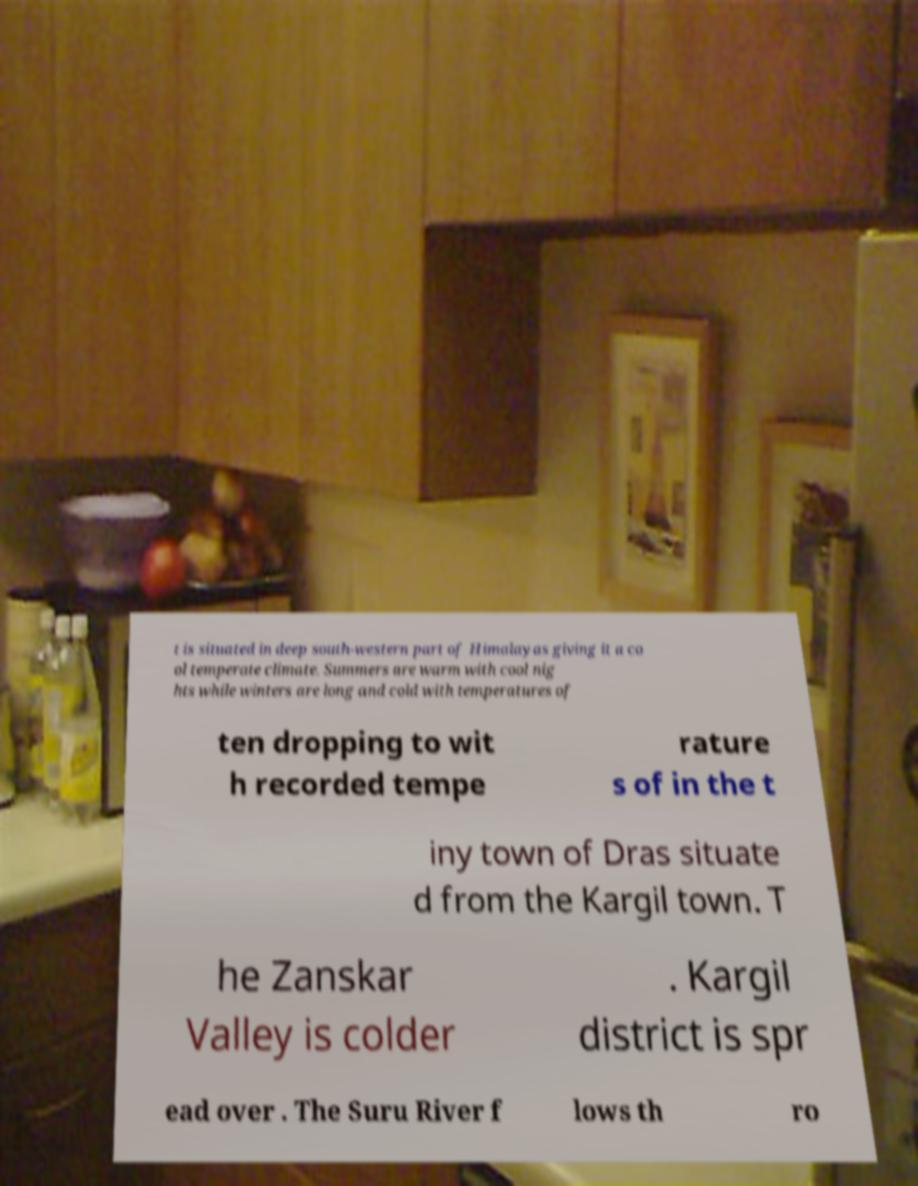Please read and relay the text visible in this image. What does it say? t is situated in deep south-western part of Himalayas giving it a co ol temperate climate. Summers are warm with cool nig hts while winters are long and cold with temperatures of ten dropping to wit h recorded tempe rature s of in the t iny town of Dras situate d from the Kargil town. T he Zanskar Valley is colder . Kargil district is spr ead over . The Suru River f lows th ro 